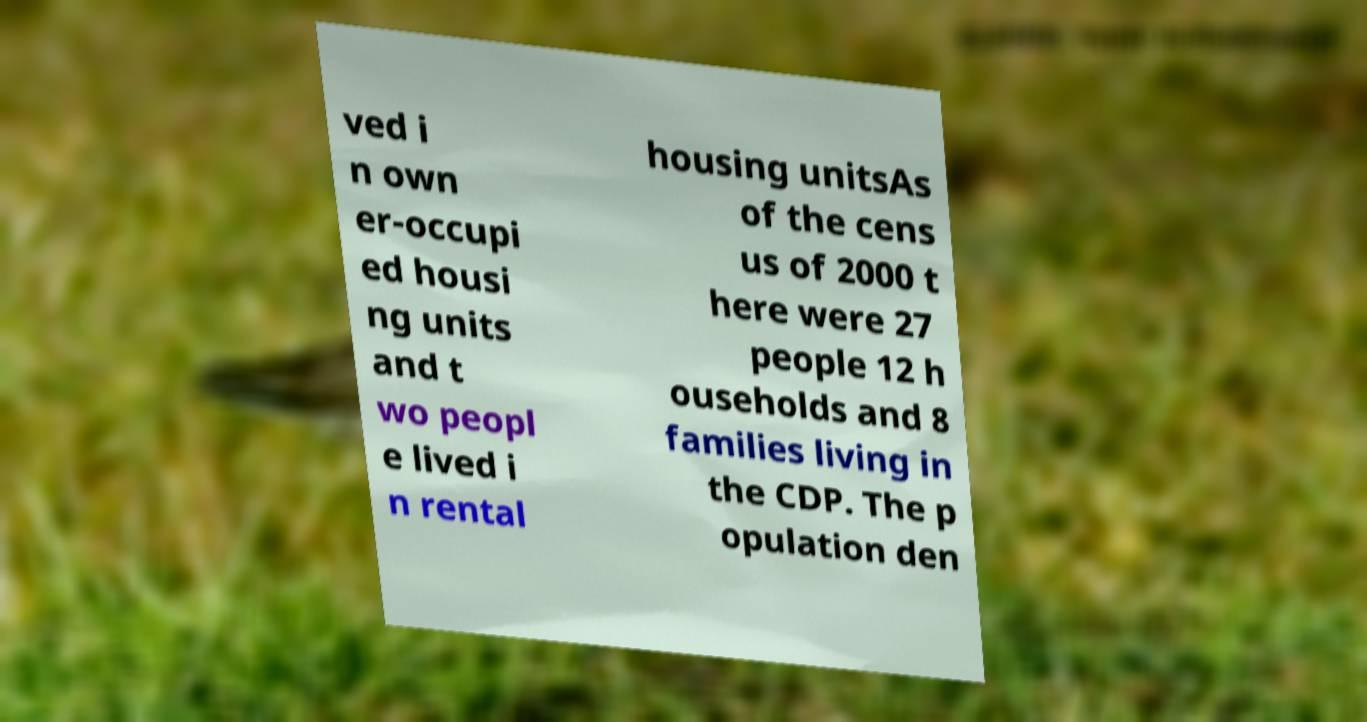I need the written content from this picture converted into text. Can you do that? ved i n own er-occupi ed housi ng units and t wo peopl e lived i n rental housing unitsAs of the cens us of 2000 t here were 27 people 12 h ouseholds and 8 families living in the CDP. The p opulation den 